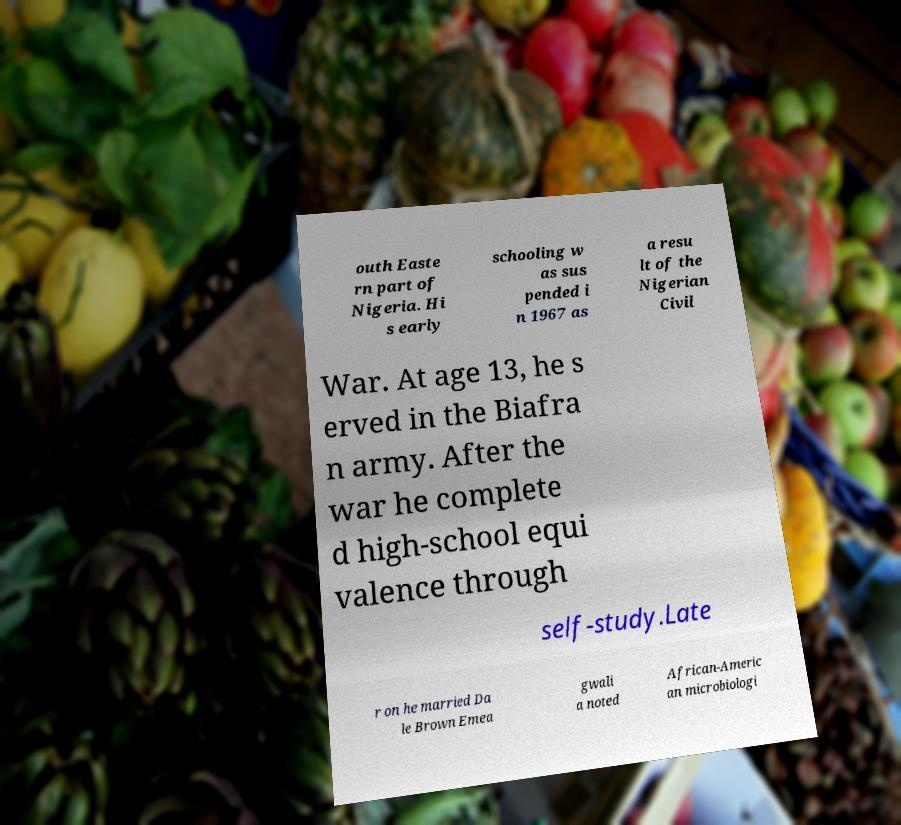What messages or text are displayed in this image? I need them in a readable, typed format. outh Easte rn part of Nigeria. Hi s early schooling w as sus pended i n 1967 as a resu lt of the Nigerian Civil War. At age 13, he s erved in the Biafra n army. After the war he complete d high-school equi valence through self-study.Late r on he married Da le Brown Emea gwali a noted African-Americ an microbiologi 